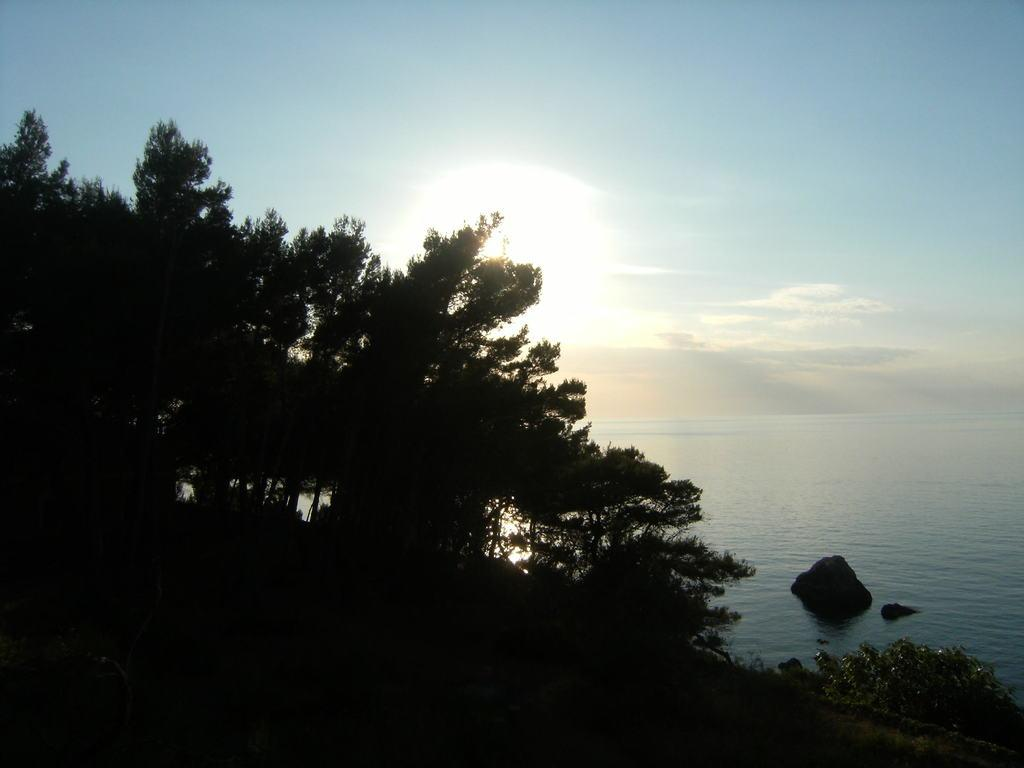What type of vegetation can be seen in the image? There are trees in the image. What is present in the water in the image? There are stones in the water in the image. What can be seen coming from the sun in the image? Sun rays are visible in the image. What is visible in the sky in the image? There are clouds in the sky in the image. What type of music can be heard coming from the trees in the image? There is no music present in the image; it only features trees, stones in the water, sun rays, and clouds in the sky. Can you see any hands in the image? There are no hands visible in the image. 